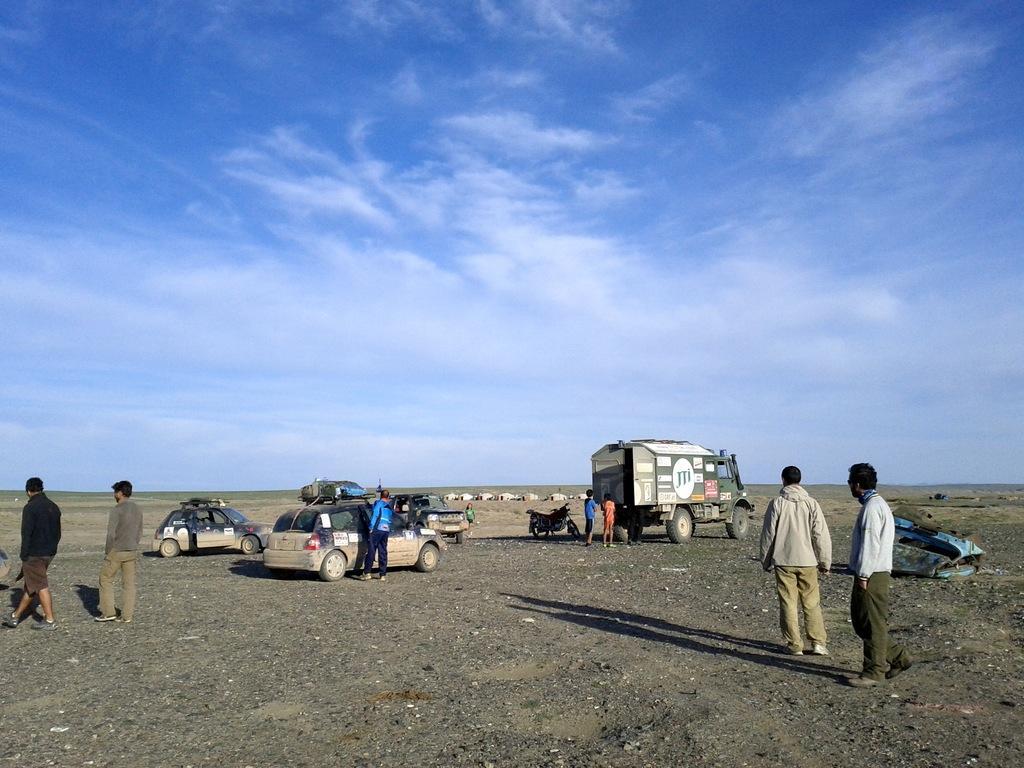Describe this image in one or two sentences. On the left side, we see two men are standing. On the right side, we see two men are standing. Beside them, we see a blue color object. In the middle, we see three people are standing. In front of them, we see the cars, a van and a bike. In the background, we see something in white color which looks like the tents. In the background, we see the sky, which is blue in color. 